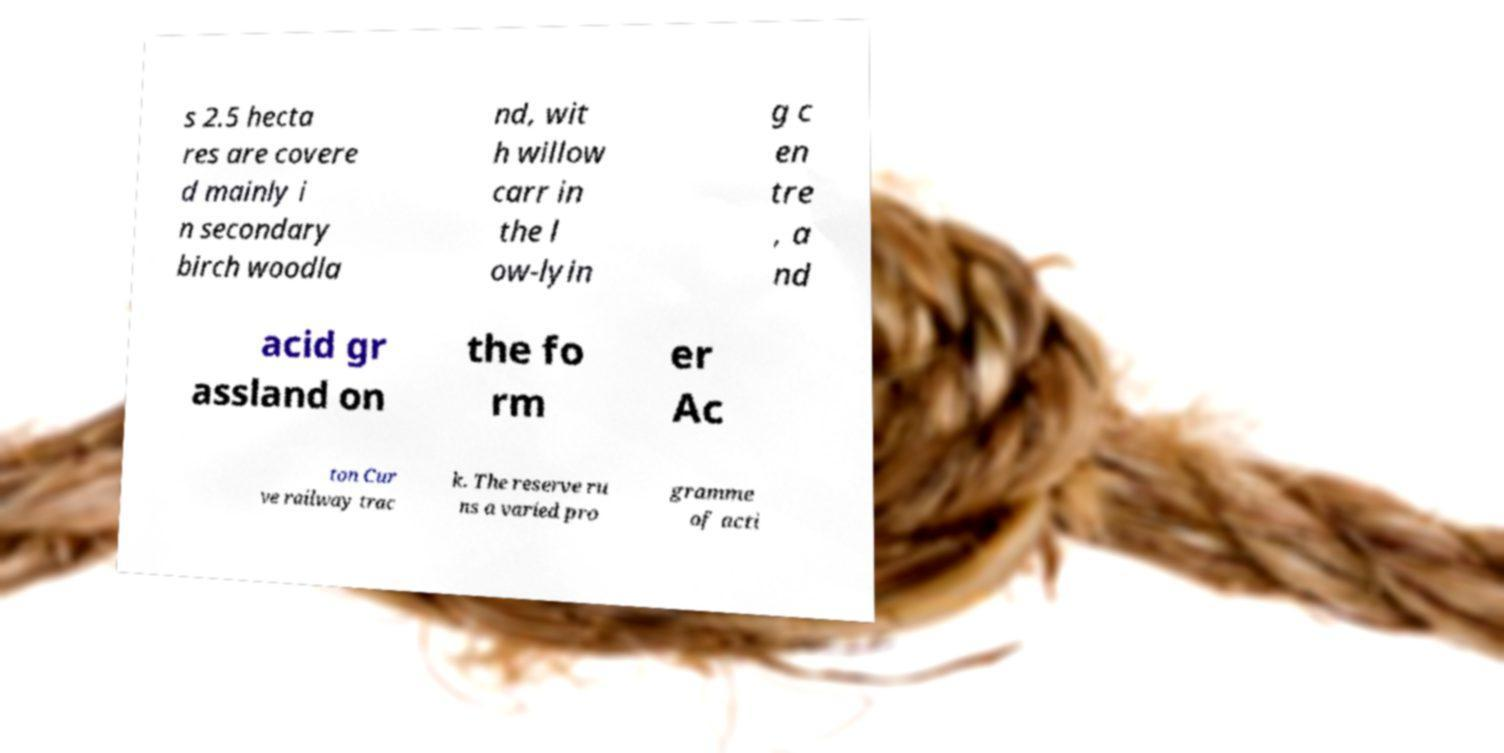Could you assist in decoding the text presented in this image and type it out clearly? s 2.5 hecta res are covere d mainly i n secondary birch woodla nd, wit h willow carr in the l ow-lyin g c en tre , a nd acid gr assland on the fo rm er Ac ton Cur ve railway trac k. The reserve ru ns a varied pro gramme of acti 